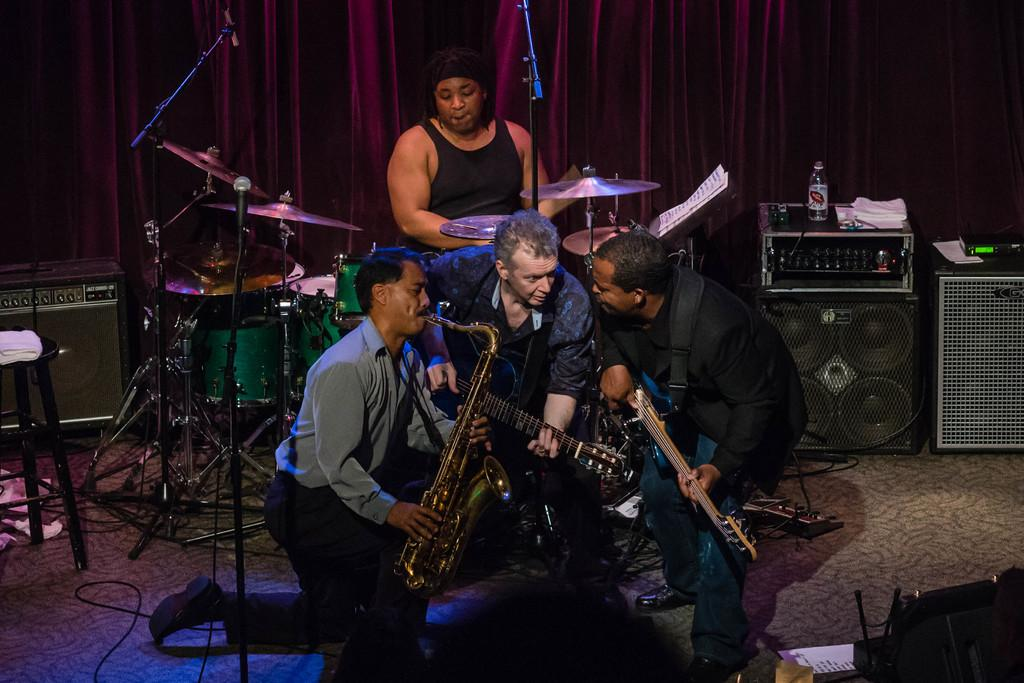What are the people on stage doing in the image? The people on stage are playing musical instruments. What objects related to sound can be seen in the image? There is a sound box and a music system in the image. What type of sugar is being used by the cattle in the image? There are no cattle or sugar present in the image. 